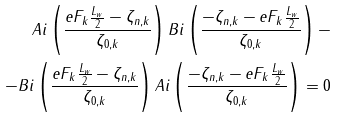<formula> <loc_0><loc_0><loc_500><loc_500>A i \left ( { \frac { e F _ { k } \frac { L _ { w } } { 2 } - \zeta _ { n , k } } { \zeta _ { 0 , k } } } \right ) B i \left ( { \frac { - \zeta _ { n , k } - e F _ { k } \frac { L _ { w } } { 2 } } { \zeta _ { 0 , k } } } \right ) - \\ - B i \left ( { \frac { e F _ { k } \frac { L _ { w } } { 2 } - \zeta _ { n , k } } { \zeta _ { 0 , k } } } \right ) A i \left ( { \frac { - \zeta _ { n , k } - e F _ { k } \frac { L _ { w } } { 2 } } { \zeta _ { 0 , k } } } \right ) = 0</formula> 